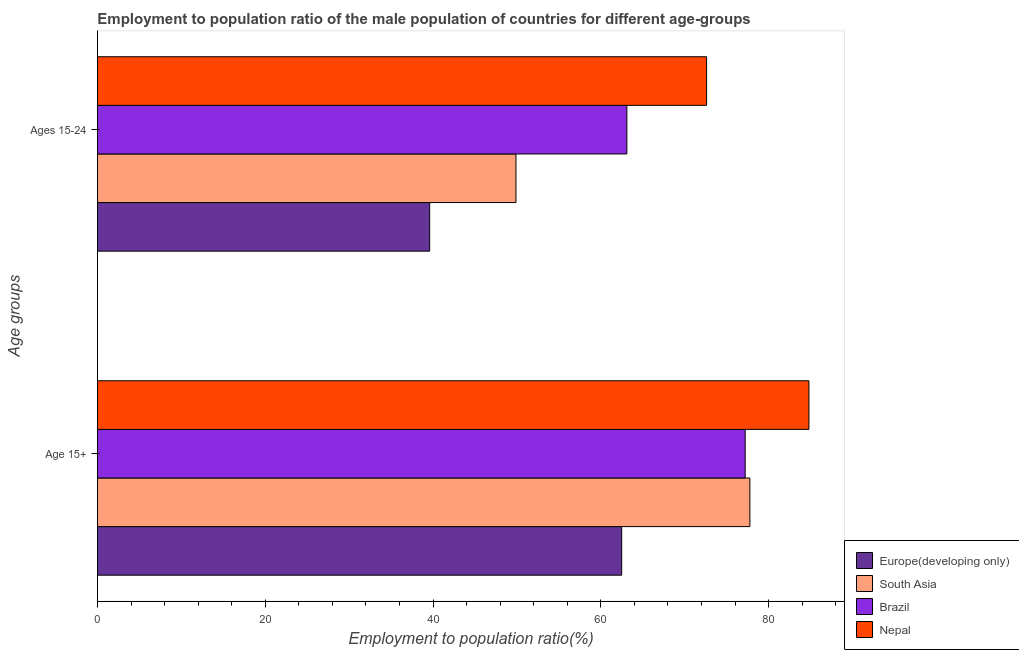Are the number of bars per tick equal to the number of legend labels?
Your answer should be very brief. Yes. How many bars are there on the 1st tick from the top?
Offer a terse response. 4. What is the label of the 2nd group of bars from the top?
Give a very brief answer. Age 15+. What is the employment to population ratio(age 15-24) in Nepal?
Give a very brief answer. 72.6. Across all countries, what is the maximum employment to population ratio(age 15+)?
Your answer should be very brief. 84.8. Across all countries, what is the minimum employment to population ratio(age 15+)?
Your answer should be very brief. 62.48. In which country was the employment to population ratio(age 15+) maximum?
Provide a short and direct response. Nepal. In which country was the employment to population ratio(age 15-24) minimum?
Ensure brevity in your answer.  Europe(developing only). What is the total employment to population ratio(age 15-24) in the graph?
Your answer should be compact. 225.17. What is the difference between the employment to population ratio(age 15-24) in Nepal and that in South Asia?
Ensure brevity in your answer.  22.72. What is the difference between the employment to population ratio(age 15-24) in Europe(developing only) and the employment to population ratio(age 15+) in South Asia?
Your answer should be compact. -38.17. What is the average employment to population ratio(age 15+) per country?
Ensure brevity in your answer.  75.56. What is the difference between the employment to population ratio(age 15-24) and employment to population ratio(age 15+) in Nepal?
Provide a succinct answer. -12.2. In how many countries, is the employment to population ratio(age 15-24) greater than 76 %?
Give a very brief answer. 0. What is the ratio of the employment to population ratio(age 15+) in Europe(developing only) to that in South Asia?
Your answer should be very brief. 0.8. In how many countries, is the employment to population ratio(age 15+) greater than the average employment to population ratio(age 15+) taken over all countries?
Provide a succinct answer. 3. What does the 4th bar from the top in Age 15+ represents?
Make the answer very short. Europe(developing only). What does the 4th bar from the bottom in Age 15+ represents?
Keep it short and to the point. Nepal. How many countries are there in the graph?
Your answer should be very brief. 4. Does the graph contain grids?
Ensure brevity in your answer.  No. Where does the legend appear in the graph?
Your answer should be compact. Bottom right. How many legend labels are there?
Your answer should be compact. 4. What is the title of the graph?
Your answer should be compact. Employment to population ratio of the male population of countries for different age-groups. What is the label or title of the X-axis?
Your answer should be compact. Employment to population ratio(%). What is the label or title of the Y-axis?
Keep it short and to the point. Age groups. What is the Employment to population ratio(%) in Europe(developing only) in Age 15+?
Give a very brief answer. 62.48. What is the Employment to population ratio(%) in South Asia in Age 15+?
Offer a terse response. 77.76. What is the Employment to population ratio(%) of Brazil in Age 15+?
Provide a succinct answer. 77.2. What is the Employment to population ratio(%) in Nepal in Age 15+?
Offer a terse response. 84.8. What is the Employment to population ratio(%) of Europe(developing only) in Ages 15-24?
Offer a terse response. 39.59. What is the Employment to population ratio(%) in South Asia in Ages 15-24?
Your answer should be very brief. 49.88. What is the Employment to population ratio(%) of Brazil in Ages 15-24?
Ensure brevity in your answer.  63.1. What is the Employment to population ratio(%) of Nepal in Ages 15-24?
Provide a succinct answer. 72.6. Across all Age groups, what is the maximum Employment to population ratio(%) of Europe(developing only)?
Offer a terse response. 62.48. Across all Age groups, what is the maximum Employment to population ratio(%) of South Asia?
Make the answer very short. 77.76. Across all Age groups, what is the maximum Employment to population ratio(%) of Brazil?
Provide a succinct answer. 77.2. Across all Age groups, what is the maximum Employment to population ratio(%) of Nepal?
Keep it short and to the point. 84.8. Across all Age groups, what is the minimum Employment to population ratio(%) in Europe(developing only)?
Offer a very short reply. 39.59. Across all Age groups, what is the minimum Employment to population ratio(%) of South Asia?
Offer a terse response. 49.88. Across all Age groups, what is the minimum Employment to population ratio(%) in Brazil?
Provide a short and direct response. 63.1. Across all Age groups, what is the minimum Employment to population ratio(%) of Nepal?
Provide a short and direct response. 72.6. What is the total Employment to population ratio(%) of Europe(developing only) in the graph?
Provide a short and direct response. 102.07. What is the total Employment to population ratio(%) of South Asia in the graph?
Make the answer very short. 127.64. What is the total Employment to population ratio(%) in Brazil in the graph?
Provide a succinct answer. 140.3. What is the total Employment to population ratio(%) in Nepal in the graph?
Provide a succinct answer. 157.4. What is the difference between the Employment to population ratio(%) of Europe(developing only) in Age 15+ and that in Ages 15-24?
Offer a terse response. 22.89. What is the difference between the Employment to population ratio(%) of South Asia in Age 15+ and that in Ages 15-24?
Your answer should be compact. 27.88. What is the difference between the Employment to population ratio(%) of Brazil in Age 15+ and that in Ages 15-24?
Make the answer very short. 14.1. What is the difference between the Employment to population ratio(%) of Europe(developing only) in Age 15+ and the Employment to population ratio(%) of South Asia in Ages 15-24?
Offer a terse response. 12.6. What is the difference between the Employment to population ratio(%) of Europe(developing only) in Age 15+ and the Employment to population ratio(%) of Brazil in Ages 15-24?
Provide a succinct answer. -0.62. What is the difference between the Employment to population ratio(%) of Europe(developing only) in Age 15+ and the Employment to population ratio(%) of Nepal in Ages 15-24?
Your answer should be compact. -10.12. What is the difference between the Employment to population ratio(%) of South Asia in Age 15+ and the Employment to population ratio(%) of Brazil in Ages 15-24?
Provide a succinct answer. 14.66. What is the difference between the Employment to population ratio(%) in South Asia in Age 15+ and the Employment to population ratio(%) in Nepal in Ages 15-24?
Provide a succinct answer. 5.16. What is the difference between the Employment to population ratio(%) of Brazil in Age 15+ and the Employment to population ratio(%) of Nepal in Ages 15-24?
Your answer should be compact. 4.6. What is the average Employment to population ratio(%) of Europe(developing only) per Age groups?
Give a very brief answer. 51.04. What is the average Employment to population ratio(%) in South Asia per Age groups?
Make the answer very short. 63.82. What is the average Employment to population ratio(%) of Brazil per Age groups?
Your answer should be compact. 70.15. What is the average Employment to population ratio(%) of Nepal per Age groups?
Provide a short and direct response. 78.7. What is the difference between the Employment to population ratio(%) of Europe(developing only) and Employment to population ratio(%) of South Asia in Age 15+?
Offer a terse response. -15.28. What is the difference between the Employment to population ratio(%) in Europe(developing only) and Employment to population ratio(%) in Brazil in Age 15+?
Provide a succinct answer. -14.72. What is the difference between the Employment to population ratio(%) in Europe(developing only) and Employment to population ratio(%) in Nepal in Age 15+?
Provide a short and direct response. -22.32. What is the difference between the Employment to population ratio(%) of South Asia and Employment to population ratio(%) of Brazil in Age 15+?
Your answer should be compact. 0.56. What is the difference between the Employment to population ratio(%) in South Asia and Employment to population ratio(%) in Nepal in Age 15+?
Give a very brief answer. -7.04. What is the difference between the Employment to population ratio(%) of Europe(developing only) and Employment to population ratio(%) of South Asia in Ages 15-24?
Your response must be concise. -10.29. What is the difference between the Employment to population ratio(%) of Europe(developing only) and Employment to population ratio(%) of Brazil in Ages 15-24?
Ensure brevity in your answer.  -23.51. What is the difference between the Employment to population ratio(%) of Europe(developing only) and Employment to population ratio(%) of Nepal in Ages 15-24?
Make the answer very short. -33.01. What is the difference between the Employment to population ratio(%) of South Asia and Employment to population ratio(%) of Brazil in Ages 15-24?
Provide a succinct answer. -13.22. What is the difference between the Employment to population ratio(%) in South Asia and Employment to population ratio(%) in Nepal in Ages 15-24?
Offer a terse response. -22.72. What is the difference between the Employment to population ratio(%) in Brazil and Employment to population ratio(%) in Nepal in Ages 15-24?
Offer a very short reply. -9.5. What is the ratio of the Employment to population ratio(%) of Europe(developing only) in Age 15+ to that in Ages 15-24?
Your answer should be compact. 1.58. What is the ratio of the Employment to population ratio(%) of South Asia in Age 15+ to that in Ages 15-24?
Your answer should be very brief. 1.56. What is the ratio of the Employment to population ratio(%) in Brazil in Age 15+ to that in Ages 15-24?
Offer a terse response. 1.22. What is the ratio of the Employment to population ratio(%) of Nepal in Age 15+ to that in Ages 15-24?
Offer a terse response. 1.17. What is the difference between the highest and the second highest Employment to population ratio(%) in Europe(developing only)?
Give a very brief answer. 22.89. What is the difference between the highest and the second highest Employment to population ratio(%) in South Asia?
Offer a very short reply. 27.88. What is the difference between the highest and the second highest Employment to population ratio(%) of Nepal?
Provide a short and direct response. 12.2. What is the difference between the highest and the lowest Employment to population ratio(%) of Europe(developing only)?
Offer a very short reply. 22.89. What is the difference between the highest and the lowest Employment to population ratio(%) of South Asia?
Offer a terse response. 27.88. What is the difference between the highest and the lowest Employment to population ratio(%) in Brazil?
Make the answer very short. 14.1. What is the difference between the highest and the lowest Employment to population ratio(%) in Nepal?
Offer a terse response. 12.2. 